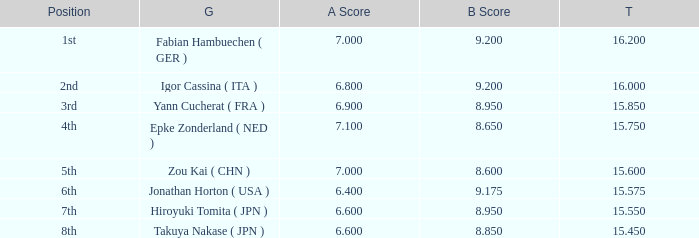Which gymnast had a b score of 8.95 and an a score less than 6.9 Hiroyuki Tomita ( JPN ). 